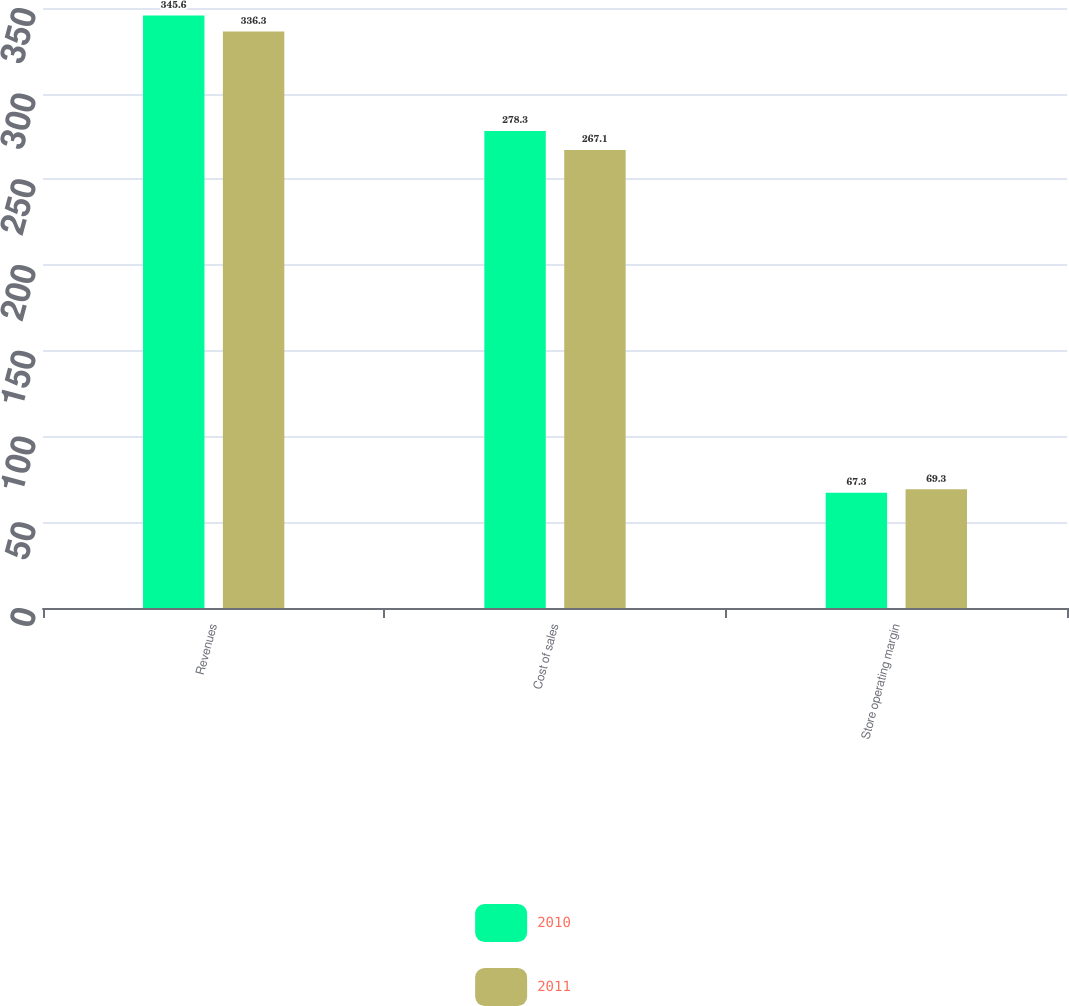Convert chart. <chart><loc_0><loc_0><loc_500><loc_500><stacked_bar_chart><ecel><fcel>Revenues<fcel>Cost of sales<fcel>Store operating margin<nl><fcel>2010<fcel>345.6<fcel>278.3<fcel>67.3<nl><fcel>2011<fcel>336.3<fcel>267.1<fcel>69.3<nl></chart> 